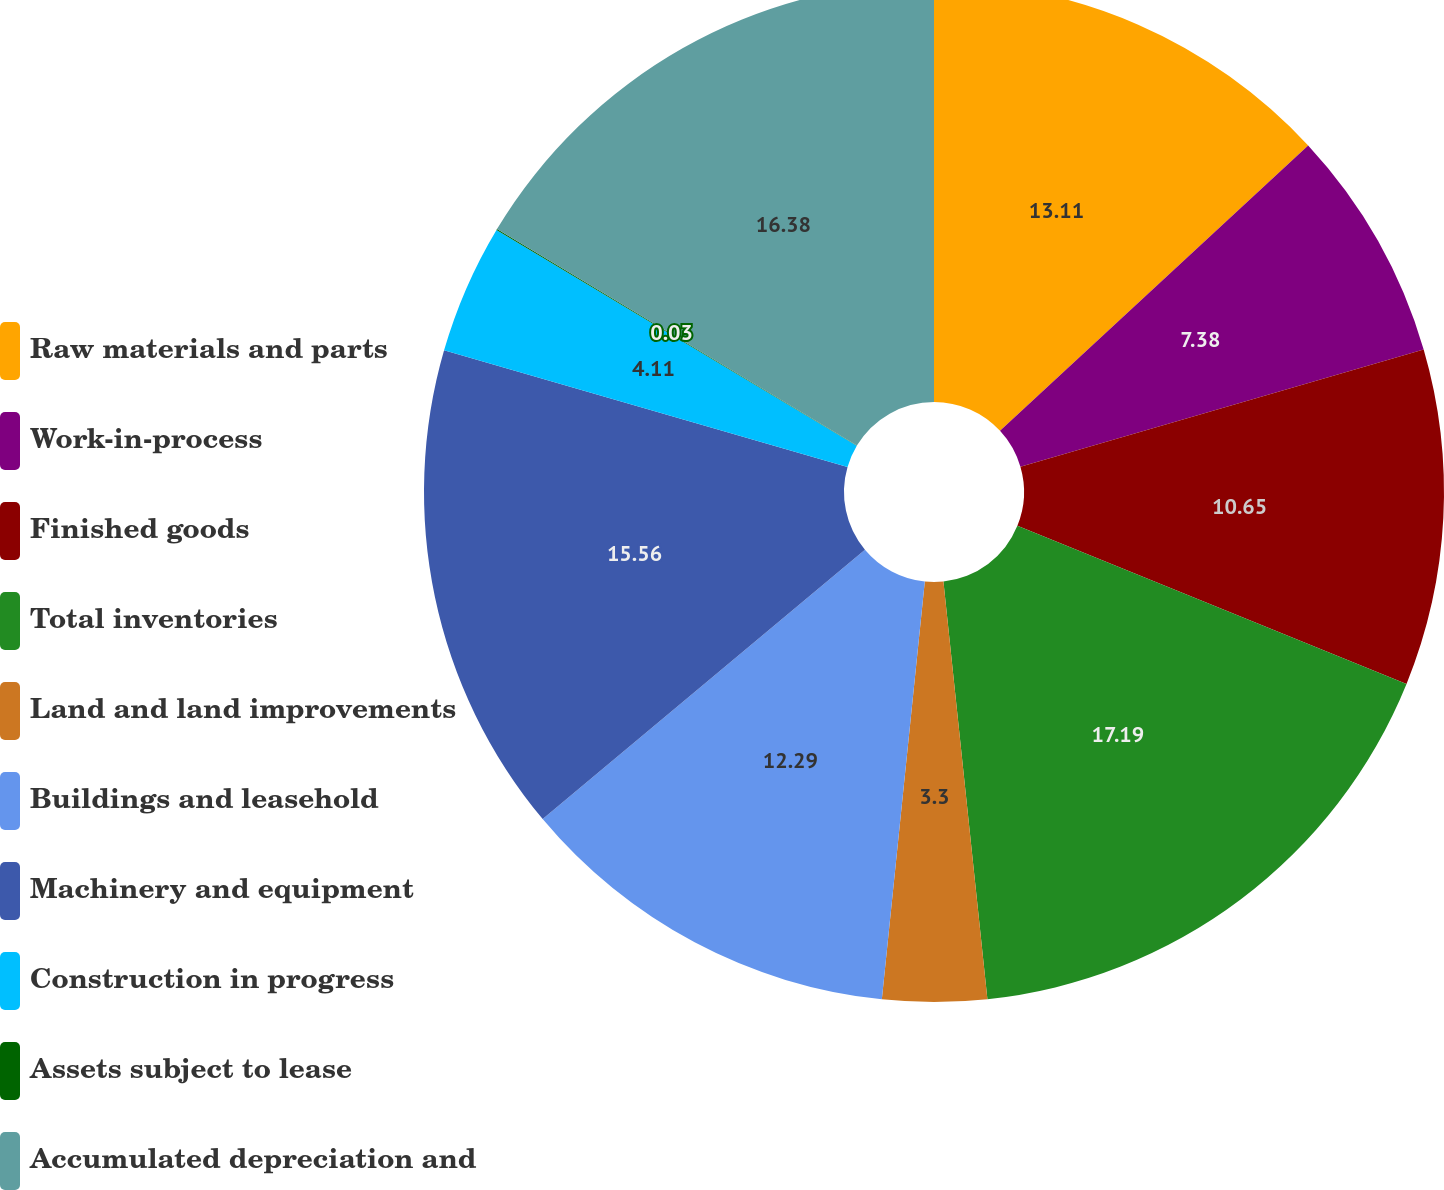<chart> <loc_0><loc_0><loc_500><loc_500><pie_chart><fcel>Raw materials and parts<fcel>Work-in-process<fcel>Finished goods<fcel>Total inventories<fcel>Land and land improvements<fcel>Buildings and leasehold<fcel>Machinery and equipment<fcel>Construction in progress<fcel>Assets subject to lease<fcel>Accumulated depreciation and<nl><fcel>13.11%<fcel>7.38%<fcel>10.65%<fcel>17.19%<fcel>3.3%<fcel>12.29%<fcel>15.56%<fcel>4.11%<fcel>0.03%<fcel>16.38%<nl></chart> 